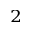Convert formula to latex. <formula><loc_0><loc_0><loc_500><loc_500>^ { 2 }</formula> 